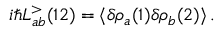Convert formula to latex. <formula><loc_0><loc_0><loc_500><loc_500>i \hbar { L } _ { a b } ^ { > } ( 1 2 ) = \langle \delta \rho _ { a } ( 1 ) \delta \rho _ { b } ( 2 ) \rangle \, .</formula> 